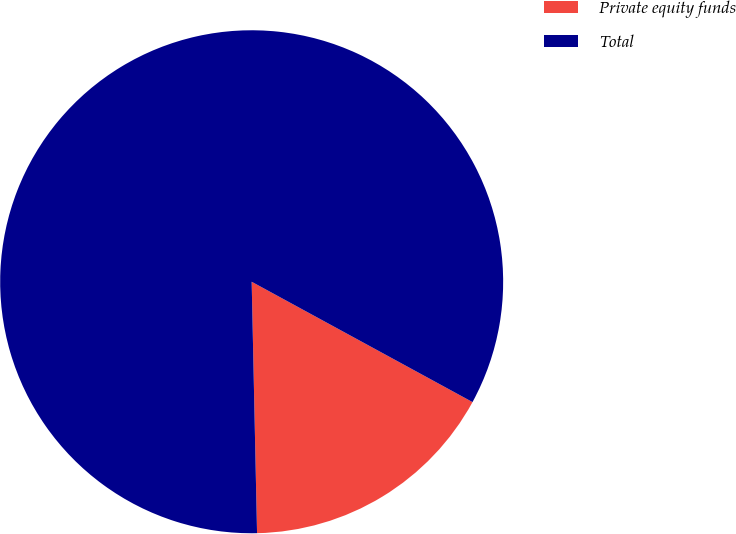Convert chart. <chart><loc_0><loc_0><loc_500><loc_500><pie_chart><fcel>Private equity funds<fcel>Total<nl><fcel>16.72%<fcel>83.28%<nl></chart> 